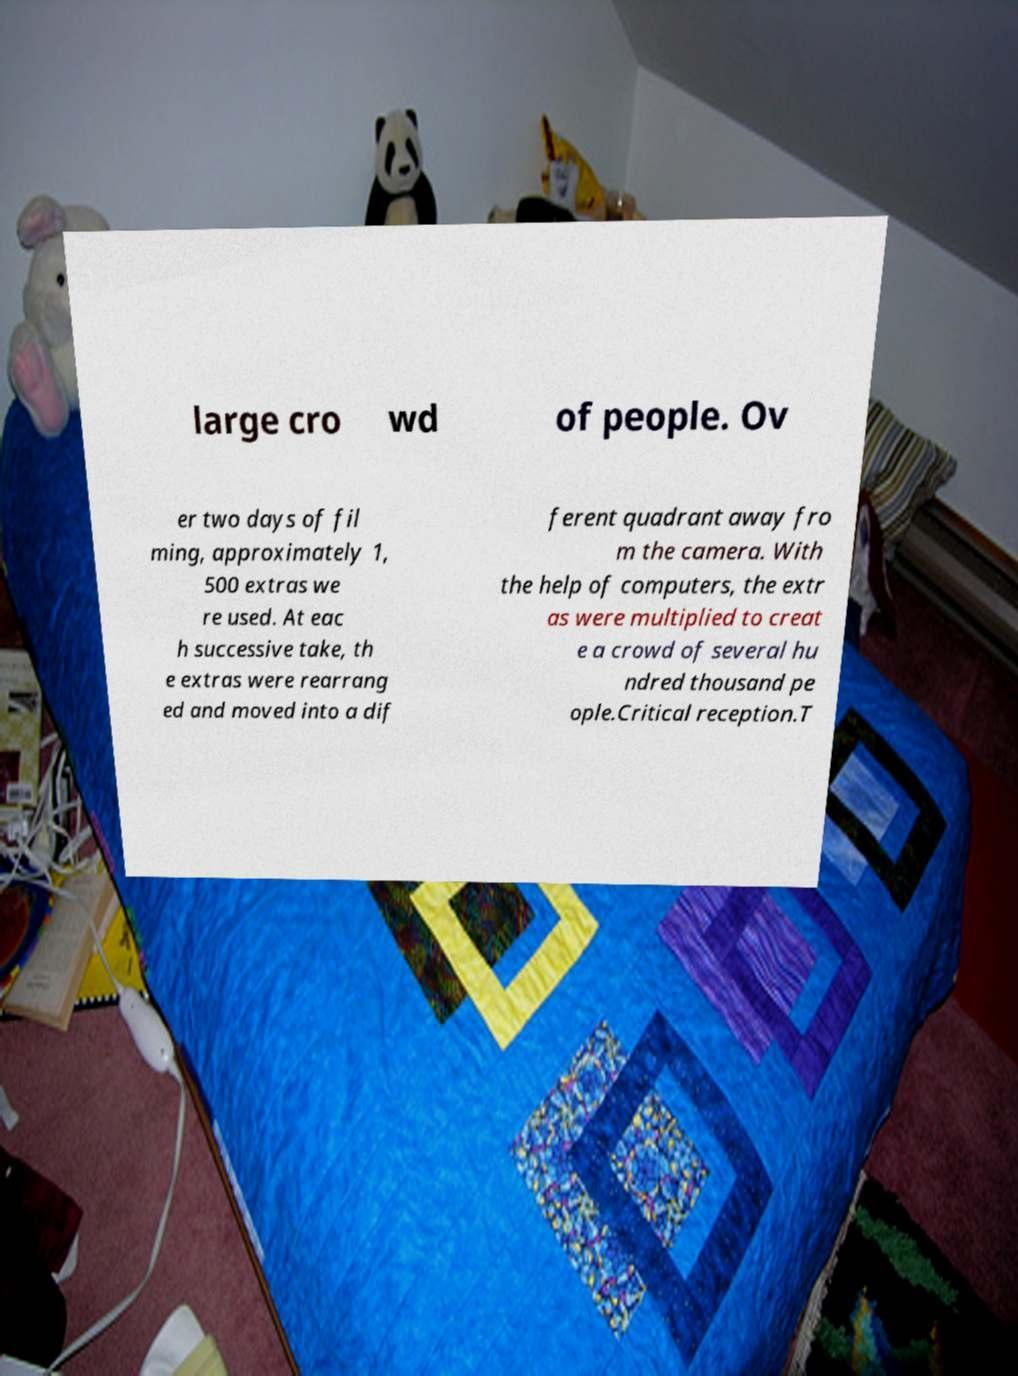Can you read and provide the text displayed in the image?This photo seems to have some interesting text. Can you extract and type it out for me? large cro wd of people. Ov er two days of fil ming, approximately 1, 500 extras we re used. At eac h successive take, th e extras were rearrang ed and moved into a dif ferent quadrant away fro m the camera. With the help of computers, the extr as were multiplied to creat e a crowd of several hu ndred thousand pe ople.Critical reception.T 